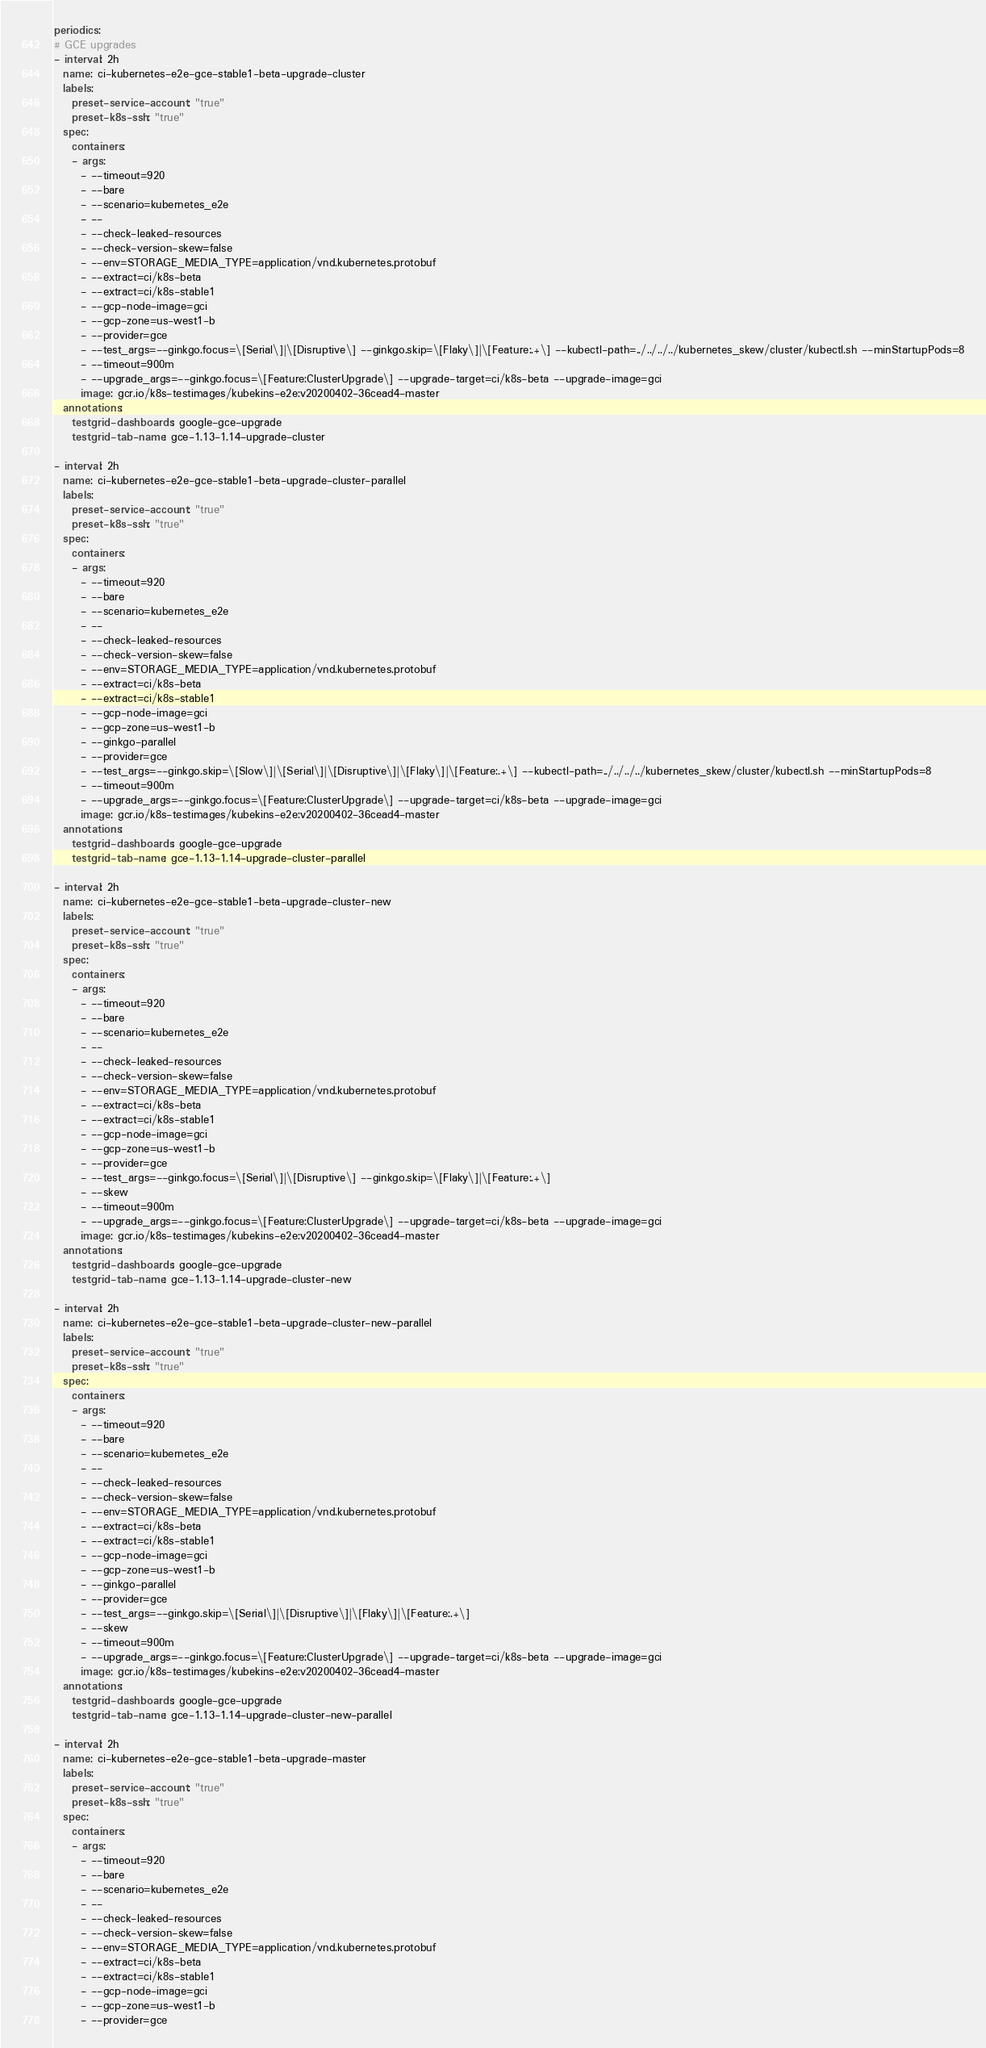Convert code to text. <code><loc_0><loc_0><loc_500><loc_500><_YAML_>periodics:
# GCE upgrades
- interval: 2h
  name: ci-kubernetes-e2e-gce-stable1-beta-upgrade-cluster
  labels:
    preset-service-account: "true"
    preset-k8s-ssh: "true"
  spec:
    containers:
    - args:
      - --timeout=920
      - --bare
      - --scenario=kubernetes_e2e
      - --
      - --check-leaked-resources
      - --check-version-skew=false
      - --env=STORAGE_MEDIA_TYPE=application/vnd.kubernetes.protobuf
      - --extract=ci/k8s-beta
      - --extract=ci/k8s-stable1
      - --gcp-node-image=gci
      - --gcp-zone=us-west1-b
      - --provider=gce
      - --test_args=--ginkgo.focus=\[Serial\]|\[Disruptive\] --ginkgo.skip=\[Flaky\]|\[Feature:.+\] --kubectl-path=../../../../kubernetes_skew/cluster/kubectl.sh --minStartupPods=8
      - --timeout=900m
      - --upgrade_args=--ginkgo.focus=\[Feature:ClusterUpgrade\] --upgrade-target=ci/k8s-beta --upgrade-image=gci
      image: gcr.io/k8s-testimages/kubekins-e2e:v20200402-36cead4-master
  annotations:
    testgrid-dashboards: google-gce-upgrade
    testgrid-tab-name: gce-1.13-1.14-upgrade-cluster

- interval: 2h
  name: ci-kubernetes-e2e-gce-stable1-beta-upgrade-cluster-parallel
  labels:
    preset-service-account: "true"
    preset-k8s-ssh: "true"
  spec:
    containers:
    - args:
      - --timeout=920
      - --bare
      - --scenario=kubernetes_e2e
      - --
      - --check-leaked-resources
      - --check-version-skew=false
      - --env=STORAGE_MEDIA_TYPE=application/vnd.kubernetes.protobuf
      - --extract=ci/k8s-beta
      - --extract=ci/k8s-stable1
      - --gcp-node-image=gci
      - --gcp-zone=us-west1-b
      - --ginkgo-parallel
      - --provider=gce
      - --test_args=--ginkgo.skip=\[Slow\]|\[Serial\]|\[Disruptive\]|\[Flaky\]|\[Feature:.+\] --kubectl-path=../../../../kubernetes_skew/cluster/kubectl.sh --minStartupPods=8
      - --timeout=900m
      - --upgrade_args=--ginkgo.focus=\[Feature:ClusterUpgrade\] --upgrade-target=ci/k8s-beta --upgrade-image=gci
      image: gcr.io/k8s-testimages/kubekins-e2e:v20200402-36cead4-master
  annotations:
    testgrid-dashboards: google-gce-upgrade
    testgrid-tab-name: gce-1.13-1.14-upgrade-cluster-parallel

- interval: 2h
  name: ci-kubernetes-e2e-gce-stable1-beta-upgrade-cluster-new
  labels:
    preset-service-account: "true"
    preset-k8s-ssh: "true"
  spec:
    containers:
    - args:
      - --timeout=920
      - --bare
      - --scenario=kubernetes_e2e
      - --
      - --check-leaked-resources
      - --check-version-skew=false
      - --env=STORAGE_MEDIA_TYPE=application/vnd.kubernetes.protobuf
      - --extract=ci/k8s-beta
      - --extract=ci/k8s-stable1
      - --gcp-node-image=gci
      - --gcp-zone=us-west1-b
      - --provider=gce
      - --test_args=--ginkgo.focus=\[Serial\]|\[Disruptive\] --ginkgo.skip=\[Flaky\]|\[Feature:.+\]
      - --skew
      - --timeout=900m
      - --upgrade_args=--ginkgo.focus=\[Feature:ClusterUpgrade\] --upgrade-target=ci/k8s-beta --upgrade-image=gci
      image: gcr.io/k8s-testimages/kubekins-e2e:v20200402-36cead4-master
  annotations:
    testgrid-dashboards: google-gce-upgrade
    testgrid-tab-name: gce-1.13-1.14-upgrade-cluster-new

- interval: 2h
  name: ci-kubernetes-e2e-gce-stable1-beta-upgrade-cluster-new-parallel
  labels:
    preset-service-account: "true"
    preset-k8s-ssh: "true"
  spec:
    containers:
    - args:
      - --timeout=920
      - --bare
      - --scenario=kubernetes_e2e
      - --
      - --check-leaked-resources
      - --check-version-skew=false
      - --env=STORAGE_MEDIA_TYPE=application/vnd.kubernetes.protobuf
      - --extract=ci/k8s-beta
      - --extract=ci/k8s-stable1
      - --gcp-node-image=gci
      - --gcp-zone=us-west1-b
      - --ginkgo-parallel
      - --provider=gce
      - --test_args=--ginkgo.skip=\[Serial\]|\[Disruptive\]|\[Flaky\]|\[Feature:.+\]
      - --skew
      - --timeout=900m
      - --upgrade_args=--ginkgo.focus=\[Feature:ClusterUpgrade\] --upgrade-target=ci/k8s-beta --upgrade-image=gci
      image: gcr.io/k8s-testimages/kubekins-e2e:v20200402-36cead4-master
  annotations:
    testgrid-dashboards: google-gce-upgrade
    testgrid-tab-name: gce-1.13-1.14-upgrade-cluster-new-parallel

- interval: 2h
  name: ci-kubernetes-e2e-gce-stable1-beta-upgrade-master
  labels:
    preset-service-account: "true"
    preset-k8s-ssh: "true"
  spec:
    containers:
    - args:
      - --timeout=920
      - --bare
      - --scenario=kubernetes_e2e
      - --
      - --check-leaked-resources
      - --check-version-skew=false
      - --env=STORAGE_MEDIA_TYPE=application/vnd.kubernetes.protobuf
      - --extract=ci/k8s-beta
      - --extract=ci/k8s-stable1
      - --gcp-node-image=gci
      - --gcp-zone=us-west1-b
      - --provider=gce</code> 